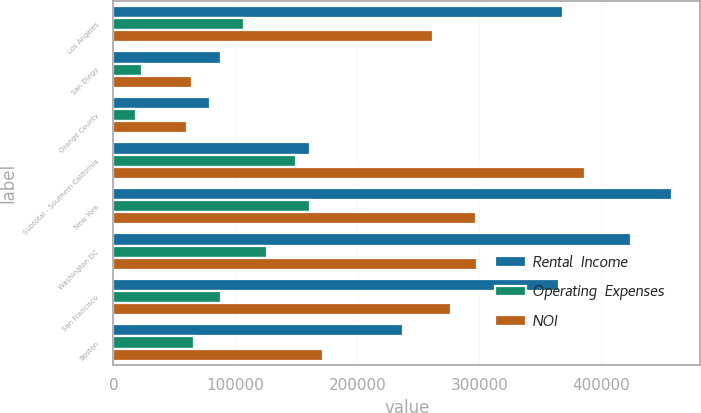Convert chart. <chart><loc_0><loc_0><loc_500><loc_500><stacked_bar_chart><ecel><fcel>Los Angeles<fcel>San Diego<fcel>Orange County<fcel>Subtotal - Southern California<fcel>New York<fcel>Washington DC<fcel>San Francisco<fcel>Boston<nl><fcel>Rental  Income<fcel>368734<fcel>88049<fcel>79602<fcel>160772<fcel>457882<fcel>424055<fcel>365019<fcel>237683<nl><fcel>Operating  Expenses<fcel>107138<fcel>23489<fcel>18931<fcel>149558<fcel>160772<fcel>126154<fcel>88141<fcel>66283<nl><fcel>NOI<fcel>261596<fcel>64560<fcel>60671<fcel>386827<fcel>297110<fcel>297901<fcel>276878<fcel>171400<nl></chart> 